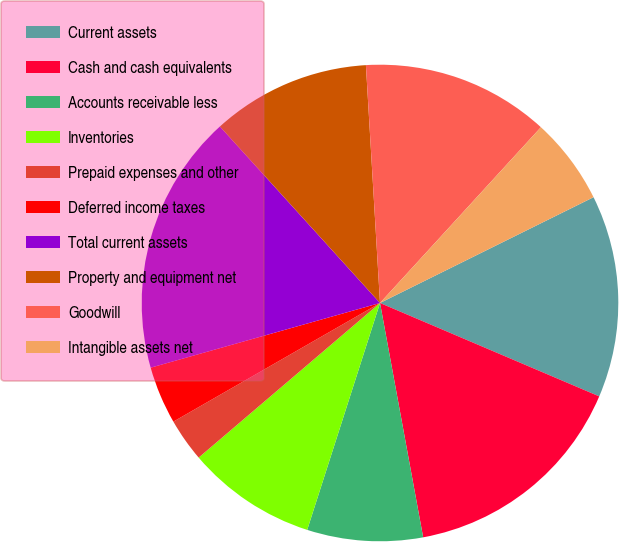<chart> <loc_0><loc_0><loc_500><loc_500><pie_chart><fcel>Current assets<fcel>Cash and cash equivalents<fcel>Accounts receivable less<fcel>Inventories<fcel>Prepaid expenses and other<fcel>Deferred income taxes<fcel>Total current assets<fcel>Property and equipment net<fcel>Goodwill<fcel>Intangible assets net<nl><fcel>13.73%<fcel>15.69%<fcel>7.84%<fcel>8.82%<fcel>2.94%<fcel>3.92%<fcel>17.65%<fcel>10.78%<fcel>12.74%<fcel>5.88%<nl></chart> 